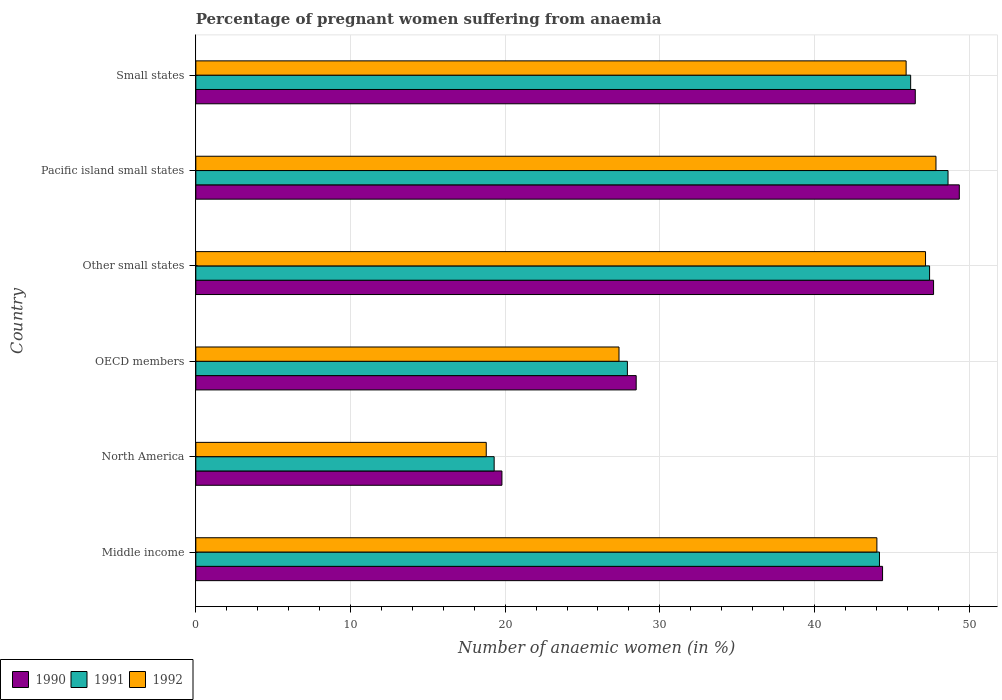How many groups of bars are there?
Offer a terse response. 6. Are the number of bars per tick equal to the number of legend labels?
Your response must be concise. Yes. How many bars are there on the 6th tick from the top?
Offer a very short reply. 3. How many bars are there on the 4th tick from the bottom?
Your answer should be compact. 3. What is the label of the 5th group of bars from the top?
Make the answer very short. North America. In how many cases, is the number of bars for a given country not equal to the number of legend labels?
Offer a terse response. 0. What is the number of anaemic women in 1992 in Small states?
Your answer should be very brief. 45.93. Across all countries, what is the maximum number of anaemic women in 1990?
Give a very brief answer. 49.37. Across all countries, what is the minimum number of anaemic women in 1990?
Offer a very short reply. 19.79. In which country was the number of anaemic women in 1990 maximum?
Give a very brief answer. Pacific island small states. In which country was the number of anaemic women in 1992 minimum?
Keep it short and to the point. North America. What is the total number of anaemic women in 1992 in the graph?
Offer a terse response. 231.14. What is the difference between the number of anaemic women in 1991 in North America and that in Small states?
Offer a terse response. -26.93. What is the difference between the number of anaemic women in 1992 in Middle income and the number of anaemic women in 1990 in North America?
Offer a very short reply. 24.25. What is the average number of anaemic women in 1992 per country?
Your answer should be compact. 38.52. What is the difference between the number of anaemic women in 1992 and number of anaemic women in 1990 in North America?
Your response must be concise. -1.01. What is the ratio of the number of anaemic women in 1992 in Middle income to that in Pacific island small states?
Provide a short and direct response. 0.92. What is the difference between the highest and the second highest number of anaemic women in 1992?
Your answer should be very brief. 0.67. What is the difference between the highest and the lowest number of anaemic women in 1992?
Give a very brief answer. 29.08. Is the sum of the number of anaemic women in 1990 in Middle income and Pacific island small states greater than the maximum number of anaemic women in 1992 across all countries?
Your answer should be very brief. Yes. What does the 1st bar from the top in North America represents?
Ensure brevity in your answer.  1992. What does the 3rd bar from the bottom in Middle income represents?
Provide a succinct answer. 1992. Is it the case that in every country, the sum of the number of anaemic women in 1992 and number of anaemic women in 1990 is greater than the number of anaemic women in 1991?
Give a very brief answer. Yes. How many bars are there?
Provide a succinct answer. 18. What is the difference between two consecutive major ticks on the X-axis?
Your response must be concise. 10. Does the graph contain grids?
Your answer should be very brief. Yes. What is the title of the graph?
Ensure brevity in your answer.  Percentage of pregnant women suffering from anaemia. What is the label or title of the X-axis?
Provide a succinct answer. Number of anaemic women (in %). What is the label or title of the Y-axis?
Your answer should be compact. Country. What is the Number of anaemic women (in %) in 1990 in Middle income?
Offer a terse response. 44.4. What is the Number of anaemic women (in %) in 1991 in Middle income?
Make the answer very short. 44.2. What is the Number of anaemic women (in %) in 1992 in Middle income?
Offer a terse response. 44.04. What is the Number of anaemic women (in %) of 1990 in North America?
Your answer should be very brief. 19.79. What is the Number of anaemic women (in %) in 1991 in North America?
Give a very brief answer. 19.29. What is the Number of anaemic women (in %) in 1992 in North America?
Give a very brief answer. 18.78. What is the Number of anaemic women (in %) in 1990 in OECD members?
Provide a succinct answer. 28.47. What is the Number of anaemic women (in %) in 1991 in OECD members?
Your response must be concise. 27.9. What is the Number of anaemic women (in %) of 1992 in OECD members?
Provide a succinct answer. 27.36. What is the Number of anaemic women (in %) in 1990 in Other small states?
Your response must be concise. 47.7. What is the Number of anaemic women (in %) in 1991 in Other small states?
Give a very brief answer. 47.44. What is the Number of anaemic women (in %) in 1992 in Other small states?
Provide a succinct answer. 47.18. What is the Number of anaemic women (in %) of 1990 in Pacific island small states?
Provide a short and direct response. 49.37. What is the Number of anaemic women (in %) of 1991 in Pacific island small states?
Ensure brevity in your answer.  48.64. What is the Number of anaemic women (in %) in 1992 in Pacific island small states?
Offer a very short reply. 47.86. What is the Number of anaemic women (in %) of 1990 in Small states?
Your response must be concise. 46.52. What is the Number of anaemic women (in %) of 1991 in Small states?
Give a very brief answer. 46.22. What is the Number of anaemic women (in %) in 1992 in Small states?
Offer a very short reply. 45.93. Across all countries, what is the maximum Number of anaemic women (in %) in 1990?
Ensure brevity in your answer.  49.37. Across all countries, what is the maximum Number of anaemic women (in %) of 1991?
Provide a short and direct response. 48.64. Across all countries, what is the maximum Number of anaemic women (in %) in 1992?
Your answer should be compact. 47.86. Across all countries, what is the minimum Number of anaemic women (in %) in 1990?
Provide a succinct answer. 19.79. Across all countries, what is the minimum Number of anaemic women (in %) in 1991?
Your response must be concise. 19.29. Across all countries, what is the minimum Number of anaemic women (in %) of 1992?
Your answer should be very brief. 18.78. What is the total Number of anaemic women (in %) in 1990 in the graph?
Provide a succinct answer. 236.26. What is the total Number of anaemic women (in %) of 1991 in the graph?
Give a very brief answer. 233.7. What is the total Number of anaemic women (in %) of 1992 in the graph?
Your answer should be compact. 231.14. What is the difference between the Number of anaemic women (in %) in 1990 in Middle income and that in North America?
Provide a succinct answer. 24.61. What is the difference between the Number of anaemic women (in %) in 1991 in Middle income and that in North America?
Your answer should be compact. 24.91. What is the difference between the Number of anaemic women (in %) in 1992 in Middle income and that in North America?
Your answer should be compact. 25.26. What is the difference between the Number of anaemic women (in %) in 1990 in Middle income and that in OECD members?
Provide a short and direct response. 15.93. What is the difference between the Number of anaemic women (in %) in 1991 in Middle income and that in OECD members?
Offer a very short reply. 16.3. What is the difference between the Number of anaemic women (in %) in 1992 in Middle income and that in OECD members?
Provide a succinct answer. 16.67. What is the difference between the Number of anaemic women (in %) in 1990 in Middle income and that in Other small states?
Give a very brief answer. -3.3. What is the difference between the Number of anaemic women (in %) of 1991 in Middle income and that in Other small states?
Give a very brief answer. -3.24. What is the difference between the Number of anaemic women (in %) of 1992 in Middle income and that in Other small states?
Offer a very short reply. -3.15. What is the difference between the Number of anaemic women (in %) in 1990 in Middle income and that in Pacific island small states?
Offer a terse response. -4.96. What is the difference between the Number of anaemic women (in %) of 1991 in Middle income and that in Pacific island small states?
Ensure brevity in your answer.  -4.43. What is the difference between the Number of anaemic women (in %) in 1992 in Middle income and that in Pacific island small states?
Keep it short and to the point. -3.82. What is the difference between the Number of anaemic women (in %) in 1990 in Middle income and that in Small states?
Offer a terse response. -2.12. What is the difference between the Number of anaemic women (in %) in 1991 in Middle income and that in Small states?
Keep it short and to the point. -2.02. What is the difference between the Number of anaemic women (in %) of 1992 in Middle income and that in Small states?
Offer a terse response. -1.89. What is the difference between the Number of anaemic women (in %) of 1990 in North America and that in OECD members?
Give a very brief answer. -8.68. What is the difference between the Number of anaemic women (in %) of 1991 in North America and that in OECD members?
Give a very brief answer. -8.61. What is the difference between the Number of anaemic women (in %) of 1992 in North America and that in OECD members?
Give a very brief answer. -8.58. What is the difference between the Number of anaemic women (in %) of 1990 in North America and that in Other small states?
Your answer should be compact. -27.91. What is the difference between the Number of anaemic women (in %) in 1991 in North America and that in Other small states?
Provide a short and direct response. -28.15. What is the difference between the Number of anaemic women (in %) of 1992 in North America and that in Other small states?
Offer a terse response. -28.4. What is the difference between the Number of anaemic women (in %) in 1990 in North America and that in Pacific island small states?
Your answer should be very brief. -29.58. What is the difference between the Number of anaemic women (in %) in 1991 in North America and that in Pacific island small states?
Make the answer very short. -29.35. What is the difference between the Number of anaemic women (in %) in 1992 in North America and that in Pacific island small states?
Offer a very short reply. -29.08. What is the difference between the Number of anaemic women (in %) of 1990 in North America and that in Small states?
Keep it short and to the point. -26.73. What is the difference between the Number of anaemic women (in %) of 1991 in North America and that in Small states?
Make the answer very short. -26.93. What is the difference between the Number of anaemic women (in %) in 1992 in North America and that in Small states?
Your answer should be compact. -27.15. What is the difference between the Number of anaemic women (in %) in 1990 in OECD members and that in Other small states?
Offer a very short reply. -19.23. What is the difference between the Number of anaemic women (in %) of 1991 in OECD members and that in Other small states?
Keep it short and to the point. -19.54. What is the difference between the Number of anaemic women (in %) in 1992 in OECD members and that in Other small states?
Your response must be concise. -19.82. What is the difference between the Number of anaemic women (in %) in 1990 in OECD members and that in Pacific island small states?
Offer a very short reply. -20.89. What is the difference between the Number of anaemic women (in %) of 1991 in OECD members and that in Pacific island small states?
Provide a succinct answer. -20.73. What is the difference between the Number of anaemic women (in %) in 1992 in OECD members and that in Pacific island small states?
Offer a terse response. -20.49. What is the difference between the Number of anaemic women (in %) of 1990 in OECD members and that in Small states?
Keep it short and to the point. -18.05. What is the difference between the Number of anaemic women (in %) of 1991 in OECD members and that in Small states?
Offer a very short reply. -18.32. What is the difference between the Number of anaemic women (in %) in 1992 in OECD members and that in Small states?
Offer a terse response. -18.57. What is the difference between the Number of anaemic women (in %) in 1990 in Other small states and that in Pacific island small states?
Provide a succinct answer. -1.66. What is the difference between the Number of anaemic women (in %) in 1991 in Other small states and that in Pacific island small states?
Make the answer very short. -1.19. What is the difference between the Number of anaemic women (in %) of 1992 in Other small states and that in Pacific island small states?
Your response must be concise. -0.67. What is the difference between the Number of anaemic women (in %) in 1990 in Other small states and that in Small states?
Your response must be concise. 1.18. What is the difference between the Number of anaemic women (in %) in 1991 in Other small states and that in Small states?
Offer a terse response. 1.22. What is the difference between the Number of anaemic women (in %) of 1992 in Other small states and that in Small states?
Keep it short and to the point. 1.26. What is the difference between the Number of anaemic women (in %) in 1990 in Pacific island small states and that in Small states?
Your answer should be very brief. 2.85. What is the difference between the Number of anaemic women (in %) in 1991 in Pacific island small states and that in Small states?
Offer a terse response. 2.42. What is the difference between the Number of anaemic women (in %) of 1992 in Pacific island small states and that in Small states?
Provide a succinct answer. 1.93. What is the difference between the Number of anaemic women (in %) in 1990 in Middle income and the Number of anaemic women (in %) in 1991 in North America?
Provide a succinct answer. 25.11. What is the difference between the Number of anaemic women (in %) in 1990 in Middle income and the Number of anaemic women (in %) in 1992 in North America?
Make the answer very short. 25.63. What is the difference between the Number of anaemic women (in %) of 1991 in Middle income and the Number of anaemic women (in %) of 1992 in North America?
Keep it short and to the point. 25.43. What is the difference between the Number of anaemic women (in %) in 1990 in Middle income and the Number of anaemic women (in %) in 1991 in OECD members?
Give a very brief answer. 16.5. What is the difference between the Number of anaemic women (in %) in 1990 in Middle income and the Number of anaemic women (in %) in 1992 in OECD members?
Ensure brevity in your answer.  17.04. What is the difference between the Number of anaemic women (in %) in 1991 in Middle income and the Number of anaemic women (in %) in 1992 in OECD members?
Offer a very short reply. 16.84. What is the difference between the Number of anaemic women (in %) in 1990 in Middle income and the Number of anaemic women (in %) in 1991 in Other small states?
Provide a succinct answer. -3.04. What is the difference between the Number of anaemic women (in %) of 1990 in Middle income and the Number of anaemic women (in %) of 1992 in Other small states?
Provide a short and direct response. -2.78. What is the difference between the Number of anaemic women (in %) in 1991 in Middle income and the Number of anaemic women (in %) in 1992 in Other small states?
Provide a succinct answer. -2.98. What is the difference between the Number of anaemic women (in %) of 1990 in Middle income and the Number of anaemic women (in %) of 1991 in Pacific island small states?
Your answer should be compact. -4.23. What is the difference between the Number of anaemic women (in %) of 1990 in Middle income and the Number of anaemic women (in %) of 1992 in Pacific island small states?
Keep it short and to the point. -3.45. What is the difference between the Number of anaemic women (in %) of 1991 in Middle income and the Number of anaemic women (in %) of 1992 in Pacific island small states?
Your answer should be very brief. -3.65. What is the difference between the Number of anaemic women (in %) of 1990 in Middle income and the Number of anaemic women (in %) of 1991 in Small states?
Make the answer very short. -1.82. What is the difference between the Number of anaemic women (in %) of 1990 in Middle income and the Number of anaemic women (in %) of 1992 in Small states?
Keep it short and to the point. -1.52. What is the difference between the Number of anaemic women (in %) of 1991 in Middle income and the Number of anaemic women (in %) of 1992 in Small states?
Keep it short and to the point. -1.72. What is the difference between the Number of anaemic women (in %) of 1990 in North America and the Number of anaemic women (in %) of 1991 in OECD members?
Your answer should be very brief. -8.11. What is the difference between the Number of anaemic women (in %) in 1990 in North America and the Number of anaemic women (in %) in 1992 in OECD members?
Provide a succinct answer. -7.57. What is the difference between the Number of anaemic women (in %) of 1991 in North America and the Number of anaemic women (in %) of 1992 in OECD members?
Give a very brief answer. -8.07. What is the difference between the Number of anaemic women (in %) in 1990 in North America and the Number of anaemic women (in %) in 1991 in Other small states?
Keep it short and to the point. -27.65. What is the difference between the Number of anaemic women (in %) in 1990 in North America and the Number of anaemic women (in %) in 1992 in Other small states?
Offer a terse response. -27.39. What is the difference between the Number of anaemic women (in %) of 1991 in North America and the Number of anaemic women (in %) of 1992 in Other small states?
Your response must be concise. -27.89. What is the difference between the Number of anaemic women (in %) in 1990 in North America and the Number of anaemic women (in %) in 1991 in Pacific island small states?
Make the answer very short. -28.85. What is the difference between the Number of anaemic women (in %) in 1990 in North America and the Number of anaemic women (in %) in 1992 in Pacific island small states?
Keep it short and to the point. -28.07. What is the difference between the Number of anaemic women (in %) in 1991 in North America and the Number of anaemic women (in %) in 1992 in Pacific island small states?
Keep it short and to the point. -28.57. What is the difference between the Number of anaemic women (in %) of 1990 in North America and the Number of anaemic women (in %) of 1991 in Small states?
Provide a short and direct response. -26.43. What is the difference between the Number of anaemic women (in %) of 1990 in North America and the Number of anaemic women (in %) of 1992 in Small states?
Keep it short and to the point. -26.14. What is the difference between the Number of anaemic women (in %) of 1991 in North America and the Number of anaemic women (in %) of 1992 in Small states?
Your response must be concise. -26.64. What is the difference between the Number of anaemic women (in %) in 1990 in OECD members and the Number of anaemic women (in %) in 1991 in Other small states?
Your response must be concise. -18.97. What is the difference between the Number of anaemic women (in %) of 1990 in OECD members and the Number of anaemic women (in %) of 1992 in Other small states?
Offer a very short reply. -18.71. What is the difference between the Number of anaemic women (in %) of 1991 in OECD members and the Number of anaemic women (in %) of 1992 in Other small states?
Your response must be concise. -19.28. What is the difference between the Number of anaemic women (in %) in 1990 in OECD members and the Number of anaemic women (in %) in 1991 in Pacific island small states?
Ensure brevity in your answer.  -20.16. What is the difference between the Number of anaemic women (in %) in 1990 in OECD members and the Number of anaemic women (in %) in 1992 in Pacific island small states?
Your answer should be compact. -19.38. What is the difference between the Number of anaemic women (in %) of 1991 in OECD members and the Number of anaemic women (in %) of 1992 in Pacific island small states?
Give a very brief answer. -19.95. What is the difference between the Number of anaemic women (in %) in 1990 in OECD members and the Number of anaemic women (in %) in 1991 in Small states?
Keep it short and to the point. -17.75. What is the difference between the Number of anaemic women (in %) in 1990 in OECD members and the Number of anaemic women (in %) in 1992 in Small states?
Ensure brevity in your answer.  -17.45. What is the difference between the Number of anaemic women (in %) in 1991 in OECD members and the Number of anaemic women (in %) in 1992 in Small states?
Offer a very short reply. -18.02. What is the difference between the Number of anaemic women (in %) of 1990 in Other small states and the Number of anaemic women (in %) of 1991 in Pacific island small states?
Your answer should be compact. -0.94. What is the difference between the Number of anaemic women (in %) in 1990 in Other small states and the Number of anaemic women (in %) in 1992 in Pacific island small states?
Your answer should be very brief. -0.15. What is the difference between the Number of anaemic women (in %) of 1991 in Other small states and the Number of anaemic women (in %) of 1992 in Pacific island small states?
Ensure brevity in your answer.  -0.41. What is the difference between the Number of anaemic women (in %) in 1990 in Other small states and the Number of anaemic women (in %) in 1991 in Small states?
Offer a very short reply. 1.48. What is the difference between the Number of anaemic women (in %) in 1990 in Other small states and the Number of anaemic women (in %) in 1992 in Small states?
Provide a succinct answer. 1.77. What is the difference between the Number of anaemic women (in %) in 1991 in Other small states and the Number of anaemic women (in %) in 1992 in Small states?
Your answer should be very brief. 1.52. What is the difference between the Number of anaemic women (in %) in 1990 in Pacific island small states and the Number of anaemic women (in %) in 1991 in Small states?
Your answer should be compact. 3.15. What is the difference between the Number of anaemic women (in %) in 1990 in Pacific island small states and the Number of anaemic women (in %) in 1992 in Small states?
Make the answer very short. 3.44. What is the difference between the Number of anaemic women (in %) in 1991 in Pacific island small states and the Number of anaemic women (in %) in 1992 in Small states?
Provide a succinct answer. 2.71. What is the average Number of anaemic women (in %) of 1990 per country?
Provide a succinct answer. 39.38. What is the average Number of anaemic women (in %) in 1991 per country?
Give a very brief answer. 38.95. What is the average Number of anaemic women (in %) of 1992 per country?
Ensure brevity in your answer.  38.52. What is the difference between the Number of anaemic women (in %) in 1990 and Number of anaemic women (in %) in 1991 in Middle income?
Ensure brevity in your answer.  0.2. What is the difference between the Number of anaemic women (in %) of 1990 and Number of anaemic women (in %) of 1992 in Middle income?
Your answer should be compact. 0.37. What is the difference between the Number of anaemic women (in %) in 1991 and Number of anaemic women (in %) in 1992 in Middle income?
Your answer should be compact. 0.17. What is the difference between the Number of anaemic women (in %) in 1990 and Number of anaemic women (in %) in 1991 in North America?
Provide a succinct answer. 0.5. What is the difference between the Number of anaemic women (in %) in 1990 and Number of anaemic women (in %) in 1992 in North America?
Give a very brief answer. 1.01. What is the difference between the Number of anaemic women (in %) in 1991 and Number of anaemic women (in %) in 1992 in North America?
Ensure brevity in your answer.  0.51. What is the difference between the Number of anaemic women (in %) of 1990 and Number of anaemic women (in %) of 1991 in OECD members?
Your response must be concise. 0.57. What is the difference between the Number of anaemic women (in %) of 1990 and Number of anaemic women (in %) of 1992 in OECD members?
Keep it short and to the point. 1.11. What is the difference between the Number of anaemic women (in %) in 1991 and Number of anaemic women (in %) in 1992 in OECD members?
Make the answer very short. 0.54. What is the difference between the Number of anaemic women (in %) in 1990 and Number of anaemic women (in %) in 1991 in Other small states?
Offer a terse response. 0.26. What is the difference between the Number of anaemic women (in %) of 1990 and Number of anaemic women (in %) of 1992 in Other small states?
Make the answer very short. 0.52. What is the difference between the Number of anaemic women (in %) in 1991 and Number of anaemic women (in %) in 1992 in Other small states?
Your answer should be compact. 0.26. What is the difference between the Number of anaemic women (in %) in 1990 and Number of anaemic women (in %) in 1991 in Pacific island small states?
Offer a terse response. 0.73. What is the difference between the Number of anaemic women (in %) in 1990 and Number of anaemic women (in %) in 1992 in Pacific island small states?
Provide a succinct answer. 1.51. What is the difference between the Number of anaemic women (in %) in 1991 and Number of anaemic women (in %) in 1992 in Pacific island small states?
Provide a short and direct response. 0.78. What is the difference between the Number of anaemic women (in %) in 1990 and Number of anaemic women (in %) in 1991 in Small states?
Offer a terse response. 0.3. What is the difference between the Number of anaemic women (in %) of 1990 and Number of anaemic women (in %) of 1992 in Small states?
Your answer should be very brief. 0.59. What is the difference between the Number of anaemic women (in %) in 1991 and Number of anaemic women (in %) in 1992 in Small states?
Offer a very short reply. 0.29. What is the ratio of the Number of anaemic women (in %) of 1990 in Middle income to that in North America?
Make the answer very short. 2.24. What is the ratio of the Number of anaemic women (in %) in 1991 in Middle income to that in North America?
Offer a terse response. 2.29. What is the ratio of the Number of anaemic women (in %) of 1992 in Middle income to that in North America?
Your response must be concise. 2.35. What is the ratio of the Number of anaemic women (in %) of 1990 in Middle income to that in OECD members?
Make the answer very short. 1.56. What is the ratio of the Number of anaemic women (in %) in 1991 in Middle income to that in OECD members?
Provide a short and direct response. 1.58. What is the ratio of the Number of anaemic women (in %) of 1992 in Middle income to that in OECD members?
Provide a succinct answer. 1.61. What is the ratio of the Number of anaemic women (in %) in 1990 in Middle income to that in Other small states?
Provide a short and direct response. 0.93. What is the ratio of the Number of anaemic women (in %) of 1991 in Middle income to that in Other small states?
Provide a succinct answer. 0.93. What is the ratio of the Number of anaemic women (in %) of 1990 in Middle income to that in Pacific island small states?
Your answer should be very brief. 0.9. What is the ratio of the Number of anaemic women (in %) of 1991 in Middle income to that in Pacific island small states?
Your response must be concise. 0.91. What is the ratio of the Number of anaemic women (in %) of 1992 in Middle income to that in Pacific island small states?
Your answer should be compact. 0.92. What is the ratio of the Number of anaemic women (in %) in 1990 in Middle income to that in Small states?
Give a very brief answer. 0.95. What is the ratio of the Number of anaemic women (in %) in 1991 in Middle income to that in Small states?
Make the answer very short. 0.96. What is the ratio of the Number of anaemic women (in %) of 1992 in Middle income to that in Small states?
Your answer should be compact. 0.96. What is the ratio of the Number of anaemic women (in %) of 1990 in North America to that in OECD members?
Your answer should be very brief. 0.7. What is the ratio of the Number of anaemic women (in %) of 1991 in North America to that in OECD members?
Your response must be concise. 0.69. What is the ratio of the Number of anaemic women (in %) of 1992 in North America to that in OECD members?
Ensure brevity in your answer.  0.69. What is the ratio of the Number of anaemic women (in %) in 1990 in North America to that in Other small states?
Give a very brief answer. 0.41. What is the ratio of the Number of anaemic women (in %) in 1991 in North America to that in Other small states?
Keep it short and to the point. 0.41. What is the ratio of the Number of anaemic women (in %) of 1992 in North America to that in Other small states?
Keep it short and to the point. 0.4. What is the ratio of the Number of anaemic women (in %) of 1990 in North America to that in Pacific island small states?
Your response must be concise. 0.4. What is the ratio of the Number of anaemic women (in %) of 1991 in North America to that in Pacific island small states?
Provide a succinct answer. 0.4. What is the ratio of the Number of anaemic women (in %) in 1992 in North America to that in Pacific island small states?
Your response must be concise. 0.39. What is the ratio of the Number of anaemic women (in %) in 1990 in North America to that in Small states?
Provide a succinct answer. 0.43. What is the ratio of the Number of anaemic women (in %) in 1991 in North America to that in Small states?
Offer a terse response. 0.42. What is the ratio of the Number of anaemic women (in %) of 1992 in North America to that in Small states?
Offer a very short reply. 0.41. What is the ratio of the Number of anaemic women (in %) in 1990 in OECD members to that in Other small states?
Provide a succinct answer. 0.6. What is the ratio of the Number of anaemic women (in %) in 1991 in OECD members to that in Other small states?
Ensure brevity in your answer.  0.59. What is the ratio of the Number of anaemic women (in %) of 1992 in OECD members to that in Other small states?
Provide a short and direct response. 0.58. What is the ratio of the Number of anaemic women (in %) in 1990 in OECD members to that in Pacific island small states?
Offer a terse response. 0.58. What is the ratio of the Number of anaemic women (in %) of 1991 in OECD members to that in Pacific island small states?
Provide a succinct answer. 0.57. What is the ratio of the Number of anaemic women (in %) in 1992 in OECD members to that in Pacific island small states?
Your response must be concise. 0.57. What is the ratio of the Number of anaemic women (in %) of 1990 in OECD members to that in Small states?
Your answer should be compact. 0.61. What is the ratio of the Number of anaemic women (in %) in 1991 in OECD members to that in Small states?
Offer a very short reply. 0.6. What is the ratio of the Number of anaemic women (in %) of 1992 in OECD members to that in Small states?
Make the answer very short. 0.6. What is the ratio of the Number of anaemic women (in %) of 1990 in Other small states to that in Pacific island small states?
Offer a very short reply. 0.97. What is the ratio of the Number of anaemic women (in %) in 1991 in Other small states to that in Pacific island small states?
Your answer should be very brief. 0.98. What is the ratio of the Number of anaemic women (in %) of 1992 in Other small states to that in Pacific island small states?
Provide a succinct answer. 0.99. What is the ratio of the Number of anaemic women (in %) of 1990 in Other small states to that in Small states?
Provide a succinct answer. 1.03. What is the ratio of the Number of anaemic women (in %) of 1991 in Other small states to that in Small states?
Provide a short and direct response. 1.03. What is the ratio of the Number of anaemic women (in %) in 1992 in Other small states to that in Small states?
Provide a succinct answer. 1.03. What is the ratio of the Number of anaemic women (in %) in 1990 in Pacific island small states to that in Small states?
Keep it short and to the point. 1.06. What is the ratio of the Number of anaemic women (in %) in 1991 in Pacific island small states to that in Small states?
Your response must be concise. 1.05. What is the ratio of the Number of anaemic women (in %) in 1992 in Pacific island small states to that in Small states?
Your response must be concise. 1.04. What is the difference between the highest and the second highest Number of anaemic women (in %) in 1990?
Offer a very short reply. 1.66. What is the difference between the highest and the second highest Number of anaemic women (in %) of 1991?
Keep it short and to the point. 1.19. What is the difference between the highest and the second highest Number of anaemic women (in %) in 1992?
Provide a short and direct response. 0.67. What is the difference between the highest and the lowest Number of anaemic women (in %) of 1990?
Offer a very short reply. 29.58. What is the difference between the highest and the lowest Number of anaemic women (in %) in 1991?
Offer a terse response. 29.35. What is the difference between the highest and the lowest Number of anaemic women (in %) in 1992?
Offer a very short reply. 29.08. 